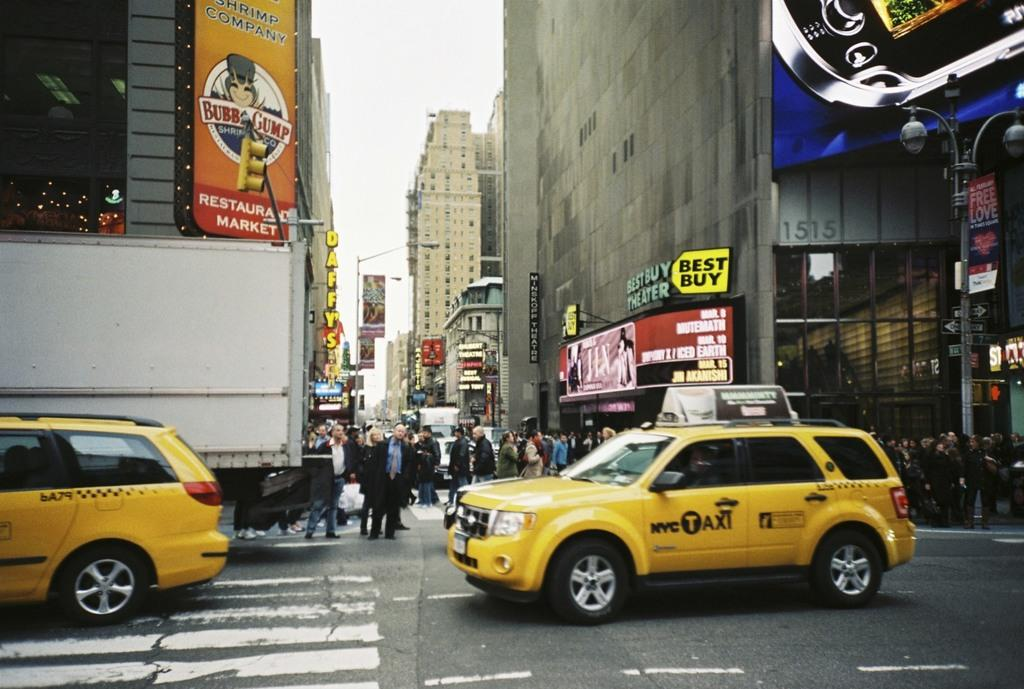<image>
Render a clear and concise summary of the photo. A busy street with multiple NYCTaxi cabs driving past a Best Buy store. 